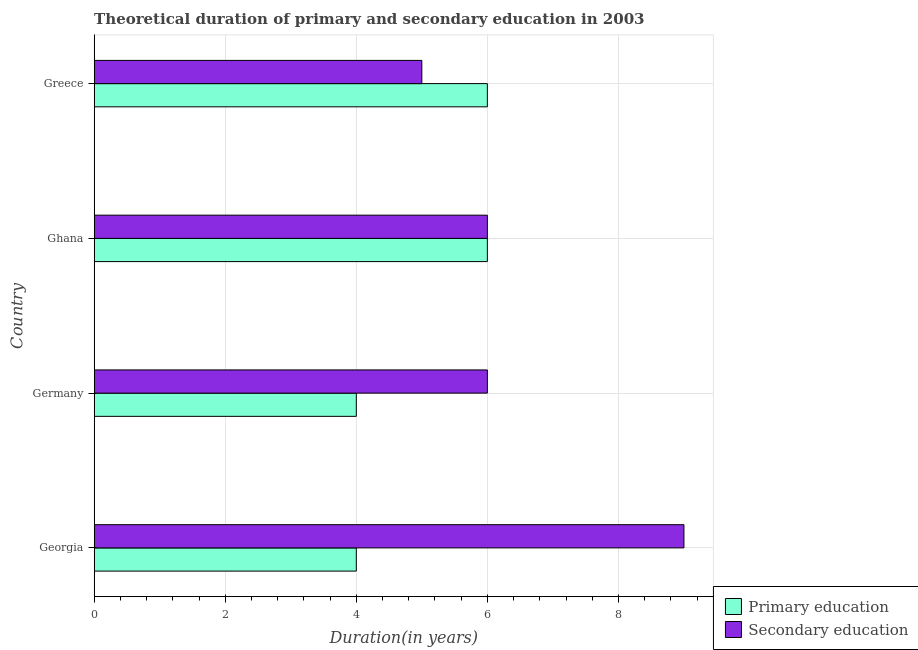How many groups of bars are there?
Offer a terse response. 4. Are the number of bars on each tick of the Y-axis equal?
Your response must be concise. Yes. What is the label of the 1st group of bars from the top?
Provide a short and direct response. Greece. What is the duration of primary education in Georgia?
Your response must be concise. 4. Across all countries, what is the maximum duration of secondary education?
Your response must be concise. 9. Across all countries, what is the minimum duration of secondary education?
Your answer should be very brief. 5. In which country was the duration of secondary education maximum?
Make the answer very short. Georgia. In which country was the duration of primary education minimum?
Your answer should be very brief. Georgia. What is the total duration of secondary education in the graph?
Offer a very short reply. 26. What is the difference between the duration of primary education in Georgia and that in Ghana?
Offer a terse response. -2. What is the difference between the duration of secondary education in Georgia and the duration of primary education in Greece?
Ensure brevity in your answer.  3. What is the difference between the duration of secondary education and duration of primary education in Germany?
Provide a short and direct response. 2. In how many countries, is the duration of secondary education greater than 5.2 years?
Your answer should be very brief. 3. Is the duration of primary education in Ghana less than that in Greece?
Offer a very short reply. No. What is the difference between the highest and the lowest duration of secondary education?
Keep it short and to the point. 4. Is the sum of the duration of secondary education in Georgia and Ghana greater than the maximum duration of primary education across all countries?
Provide a succinct answer. Yes. What does the 1st bar from the top in Greece represents?
Your response must be concise. Secondary education. What does the 1st bar from the bottom in Greece represents?
Provide a succinct answer. Primary education. How many bars are there?
Ensure brevity in your answer.  8. How many countries are there in the graph?
Offer a very short reply. 4. What is the difference between two consecutive major ticks on the X-axis?
Offer a terse response. 2. Are the values on the major ticks of X-axis written in scientific E-notation?
Your answer should be compact. No. Does the graph contain any zero values?
Keep it short and to the point. No. Does the graph contain grids?
Ensure brevity in your answer.  Yes. Where does the legend appear in the graph?
Give a very brief answer. Bottom right. How many legend labels are there?
Give a very brief answer. 2. How are the legend labels stacked?
Give a very brief answer. Vertical. What is the title of the graph?
Provide a succinct answer. Theoretical duration of primary and secondary education in 2003. What is the label or title of the X-axis?
Provide a succinct answer. Duration(in years). What is the label or title of the Y-axis?
Offer a terse response. Country. What is the Duration(in years) of Primary education in Georgia?
Give a very brief answer. 4. What is the Duration(in years) in Primary education in Ghana?
Provide a short and direct response. 6. What is the Duration(in years) of Secondary education in Ghana?
Make the answer very short. 6. What is the Duration(in years) in Primary education in Greece?
Provide a short and direct response. 6. What is the Duration(in years) in Secondary education in Greece?
Your answer should be very brief. 5. Across all countries, what is the minimum Duration(in years) of Primary education?
Provide a succinct answer. 4. What is the total Duration(in years) of Secondary education in the graph?
Provide a succinct answer. 26. What is the difference between the Duration(in years) in Primary education in Georgia and that in Germany?
Ensure brevity in your answer.  0. What is the difference between the Duration(in years) in Primary education in Georgia and that in Ghana?
Your response must be concise. -2. What is the difference between the Duration(in years) of Primary education in Georgia and that in Greece?
Make the answer very short. -2. What is the difference between the Duration(in years) in Primary education in Germany and that in Ghana?
Keep it short and to the point. -2. What is the difference between the Duration(in years) in Primary education in Georgia and the Duration(in years) in Secondary education in Ghana?
Ensure brevity in your answer.  -2. What is the difference between the Duration(in years) of Primary education in Germany and the Duration(in years) of Secondary education in Ghana?
Give a very brief answer. -2. What is the difference between the Duration(in years) in Primary education in Ghana and the Duration(in years) in Secondary education in Greece?
Offer a very short reply. 1. What is the average Duration(in years) of Primary education per country?
Your answer should be very brief. 5. What is the average Duration(in years) in Secondary education per country?
Make the answer very short. 6.5. What is the difference between the Duration(in years) in Primary education and Duration(in years) in Secondary education in Georgia?
Keep it short and to the point. -5. What is the difference between the Duration(in years) in Primary education and Duration(in years) in Secondary education in Ghana?
Your answer should be compact. 0. What is the ratio of the Duration(in years) in Secondary education in Georgia to that in Ghana?
Make the answer very short. 1.5. What is the ratio of the Duration(in years) of Primary education in Georgia to that in Greece?
Provide a succinct answer. 0.67. What is the ratio of the Duration(in years) of Secondary education in Germany to that in Ghana?
Your response must be concise. 1. What is the ratio of the Duration(in years) in Secondary education in Germany to that in Greece?
Make the answer very short. 1.2. What is the ratio of the Duration(in years) of Secondary education in Ghana to that in Greece?
Your answer should be very brief. 1.2. What is the difference between the highest and the second highest Duration(in years) in Secondary education?
Give a very brief answer. 3. What is the difference between the highest and the lowest Duration(in years) in Primary education?
Ensure brevity in your answer.  2. What is the difference between the highest and the lowest Duration(in years) in Secondary education?
Your response must be concise. 4. 